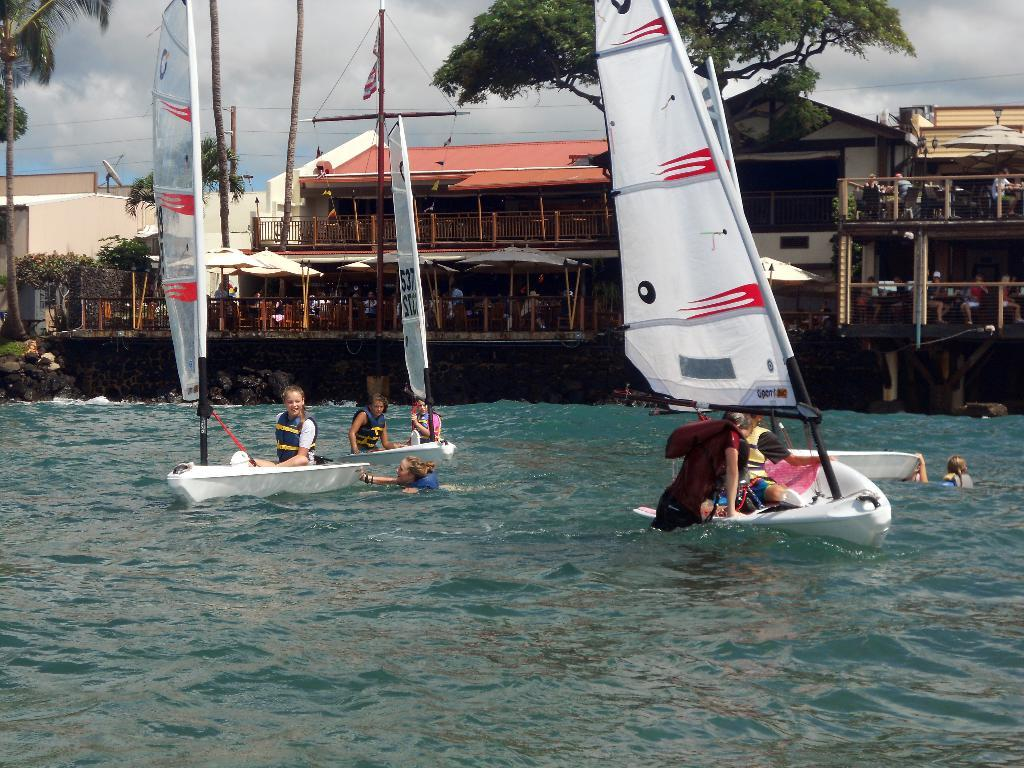What can be seen floating on the water in the image? There are two small boats in the water. What type of structure is present in the image? There is a wooden shed house in the image. What type of plant life is visible in the image? There is a tree in the image. What type of soup is being served in the wooden shed house? There is no soup or indication of food in the image; it only features two small boats, a wooden shed house, and a tree. 